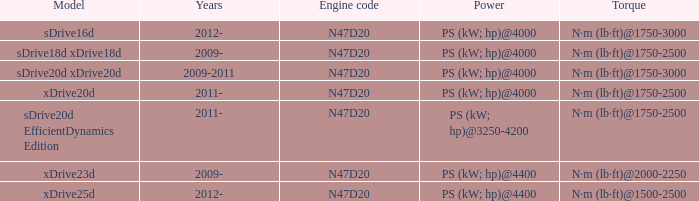What is the torque of the xdrive20d model, which has a power of ps (kw; hp)@4000? N·m (lb·ft)@1750-2500. 